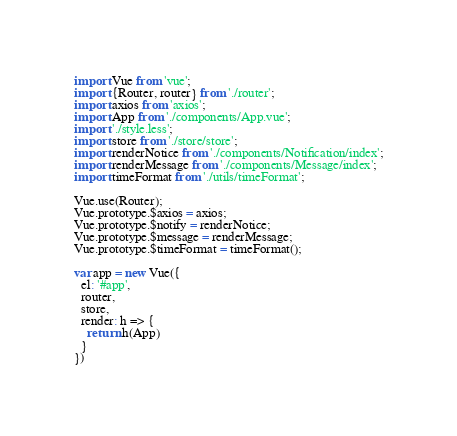<code> <loc_0><loc_0><loc_500><loc_500><_JavaScript_>import Vue from 'vue';
import {Router, router} from './router';
import axios from 'axios';
import App from './components/App.vue';
import './style.less';
import store from './store/store';
import renderNotice from './components/Notification/index';
import renderMessage from './components/Message/index';
import timeFormat from './utils/timeFormat';

Vue.use(Router);
Vue.prototype.$axios = axios;
Vue.prototype.$notify = renderNotice;
Vue.prototype.$message = renderMessage;
Vue.prototype.$timeFormat = timeFormat();

var app = new Vue({
  el: '#app',
  router,
  store,
  render: h => {
    return h(App)
  }
})</code> 